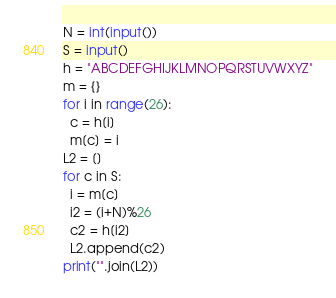<code> <loc_0><loc_0><loc_500><loc_500><_Python_>N = int(input())
S = input()
h = "ABCDEFGHIJKLMNOPQRSTUVWXYZ"
m = {}
for i in range(26):
  c = h[i]
  m[c] = i
L2 = []
for c in S:
  i = m[c]
  i2 = (i+N)%26
  c2 = h[i2]
  L2.append(c2)
print("".join(L2))
</code> 